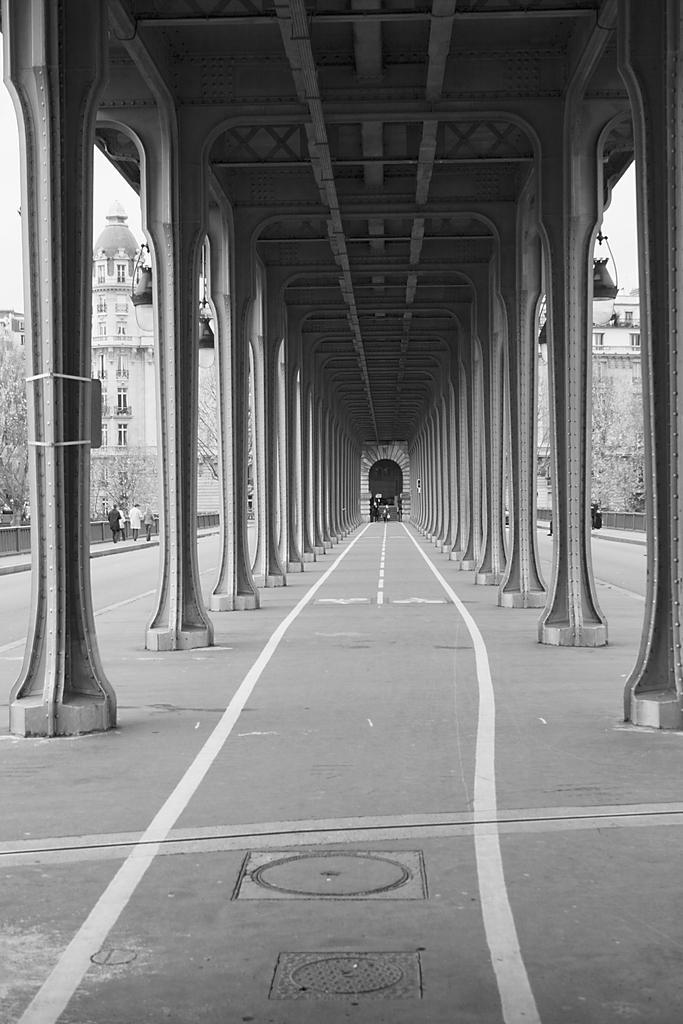Can you describe this image briefly? We can see pillars and lights. In the background we can see people, fences, buildings, trees and sky. 